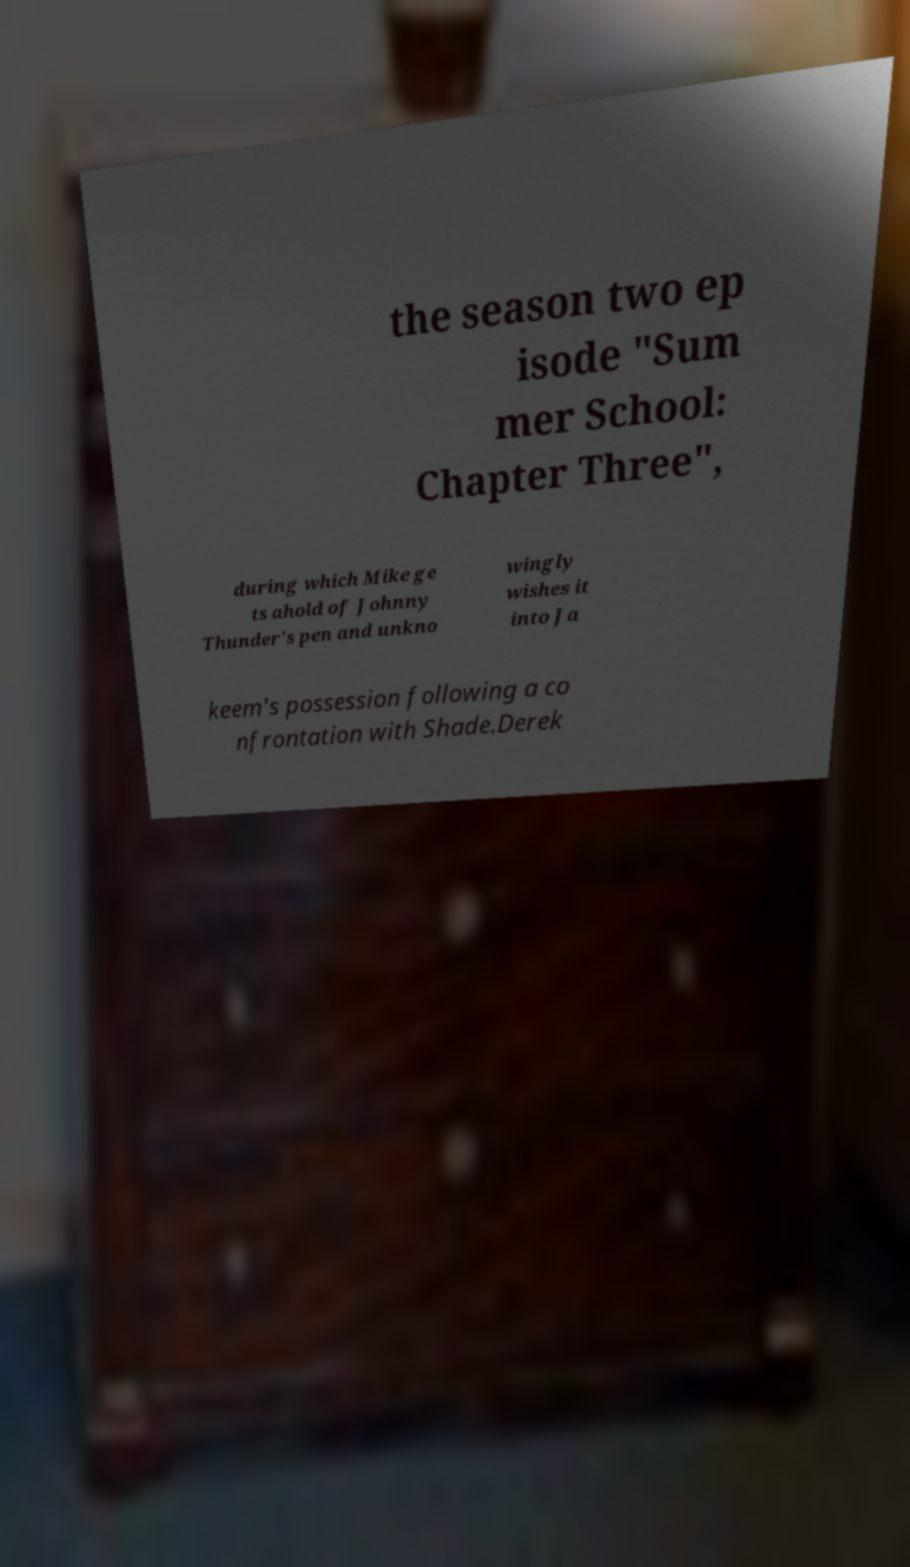Could you assist in decoding the text presented in this image and type it out clearly? the season two ep isode "Sum mer School: Chapter Three", during which Mike ge ts ahold of Johnny Thunder's pen and unkno wingly wishes it into Ja keem's possession following a co nfrontation with Shade.Derek 